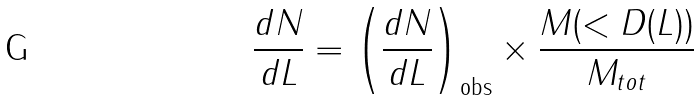<formula> <loc_0><loc_0><loc_500><loc_500>\frac { d N } { d L } = \left ( \frac { d N } { d L } \right ) _ { \text {obs} } \times \frac { M ( < D ( L ) ) } { M _ { t o t } }</formula> 